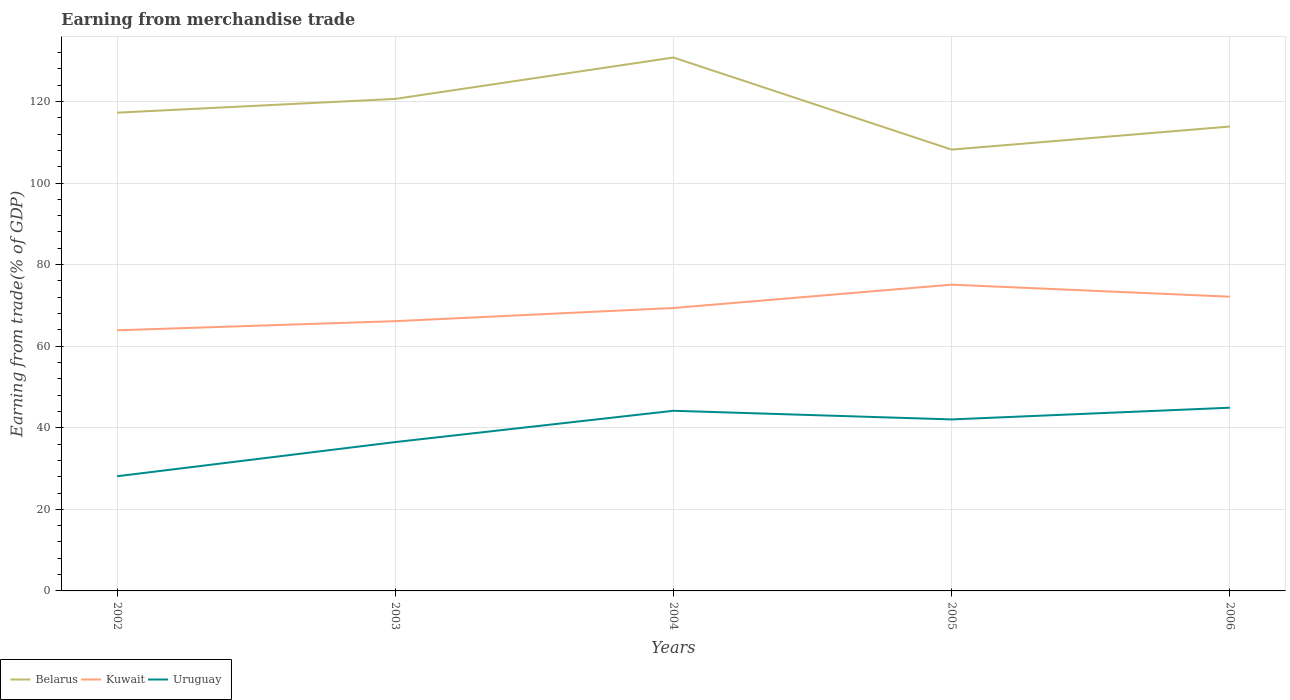Across all years, what is the maximum earnings from trade in Belarus?
Make the answer very short. 108.2. What is the total earnings from trade in Belarus in the graph?
Ensure brevity in your answer.  12.44. What is the difference between the highest and the second highest earnings from trade in Kuwait?
Your response must be concise. 11.19. What is the difference between the highest and the lowest earnings from trade in Kuwait?
Offer a very short reply. 3. How many lines are there?
Offer a very short reply. 3. What is the difference between two consecutive major ticks on the Y-axis?
Offer a terse response. 20. Does the graph contain any zero values?
Make the answer very short. No. Does the graph contain grids?
Offer a terse response. Yes. What is the title of the graph?
Give a very brief answer. Earning from merchandise trade. What is the label or title of the Y-axis?
Offer a very short reply. Earning from trade(% of GDP). What is the Earning from trade(% of GDP) of Belarus in 2002?
Give a very brief answer. 117.25. What is the Earning from trade(% of GDP) in Kuwait in 2002?
Offer a terse response. 63.9. What is the Earning from trade(% of GDP) in Uruguay in 2002?
Provide a short and direct response. 28.11. What is the Earning from trade(% of GDP) in Belarus in 2003?
Offer a terse response. 120.63. What is the Earning from trade(% of GDP) of Kuwait in 2003?
Offer a terse response. 66.14. What is the Earning from trade(% of GDP) of Uruguay in 2003?
Your response must be concise. 36.49. What is the Earning from trade(% of GDP) in Belarus in 2004?
Keep it short and to the point. 130.78. What is the Earning from trade(% of GDP) in Kuwait in 2004?
Offer a terse response. 69.36. What is the Earning from trade(% of GDP) of Uruguay in 2004?
Your answer should be compact. 44.17. What is the Earning from trade(% of GDP) of Belarus in 2005?
Your answer should be very brief. 108.2. What is the Earning from trade(% of GDP) in Kuwait in 2005?
Give a very brief answer. 75.09. What is the Earning from trade(% of GDP) in Uruguay in 2005?
Your answer should be compact. 42.05. What is the Earning from trade(% of GDP) in Belarus in 2006?
Provide a succinct answer. 113.86. What is the Earning from trade(% of GDP) in Kuwait in 2006?
Provide a succinct answer. 72.14. What is the Earning from trade(% of GDP) in Uruguay in 2006?
Offer a very short reply. 44.92. Across all years, what is the maximum Earning from trade(% of GDP) in Belarus?
Your answer should be compact. 130.78. Across all years, what is the maximum Earning from trade(% of GDP) of Kuwait?
Your answer should be very brief. 75.09. Across all years, what is the maximum Earning from trade(% of GDP) of Uruguay?
Offer a terse response. 44.92. Across all years, what is the minimum Earning from trade(% of GDP) of Belarus?
Provide a succinct answer. 108.2. Across all years, what is the minimum Earning from trade(% of GDP) of Kuwait?
Provide a succinct answer. 63.9. Across all years, what is the minimum Earning from trade(% of GDP) of Uruguay?
Your response must be concise. 28.11. What is the total Earning from trade(% of GDP) in Belarus in the graph?
Give a very brief answer. 590.73. What is the total Earning from trade(% of GDP) in Kuwait in the graph?
Make the answer very short. 346.63. What is the total Earning from trade(% of GDP) of Uruguay in the graph?
Offer a terse response. 195.74. What is the difference between the Earning from trade(% of GDP) of Belarus in 2002 and that in 2003?
Provide a short and direct response. -3.38. What is the difference between the Earning from trade(% of GDP) in Kuwait in 2002 and that in 2003?
Give a very brief answer. -2.24. What is the difference between the Earning from trade(% of GDP) of Uruguay in 2002 and that in 2003?
Offer a terse response. -8.38. What is the difference between the Earning from trade(% of GDP) of Belarus in 2002 and that in 2004?
Offer a terse response. -13.53. What is the difference between the Earning from trade(% of GDP) of Kuwait in 2002 and that in 2004?
Offer a very short reply. -5.46. What is the difference between the Earning from trade(% of GDP) in Uruguay in 2002 and that in 2004?
Give a very brief answer. -16.06. What is the difference between the Earning from trade(% of GDP) in Belarus in 2002 and that in 2005?
Your answer should be compact. 9.06. What is the difference between the Earning from trade(% of GDP) in Kuwait in 2002 and that in 2005?
Give a very brief answer. -11.19. What is the difference between the Earning from trade(% of GDP) of Uruguay in 2002 and that in 2005?
Your answer should be compact. -13.94. What is the difference between the Earning from trade(% of GDP) in Belarus in 2002 and that in 2006?
Your answer should be very brief. 3.39. What is the difference between the Earning from trade(% of GDP) in Kuwait in 2002 and that in 2006?
Your response must be concise. -8.24. What is the difference between the Earning from trade(% of GDP) of Uruguay in 2002 and that in 2006?
Offer a terse response. -16.81. What is the difference between the Earning from trade(% of GDP) in Belarus in 2003 and that in 2004?
Offer a very short reply. -10.15. What is the difference between the Earning from trade(% of GDP) in Kuwait in 2003 and that in 2004?
Keep it short and to the point. -3.22. What is the difference between the Earning from trade(% of GDP) of Uruguay in 2003 and that in 2004?
Make the answer very short. -7.67. What is the difference between the Earning from trade(% of GDP) of Belarus in 2003 and that in 2005?
Your response must be concise. 12.44. What is the difference between the Earning from trade(% of GDP) in Kuwait in 2003 and that in 2005?
Make the answer very short. -8.95. What is the difference between the Earning from trade(% of GDP) in Uruguay in 2003 and that in 2005?
Ensure brevity in your answer.  -5.55. What is the difference between the Earning from trade(% of GDP) in Belarus in 2003 and that in 2006?
Provide a succinct answer. 6.77. What is the difference between the Earning from trade(% of GDP) in Kuwait in 2003 and that in 2006?
Your response must be concise. -6. What is the difference between the Earning from trade(% of GDP) in Uruguay in 2003 and that in 2006?
Provide a succinct answer. -8.43. What is the difference between the Earning from trade(% of GDP) of Belarus in 2004 and that in 2005?
Provide a short and direct response. 22.58. What is the difference between the Earning from trade(% of GDP) of Kuwait in 2004 and that in 2005?
Make the answer very short. -5.72. What is the difference between the Earning from trade(% of GDP) of Uruguay in 2004 and that in 2005?
Your answer should be very brief. 2.12. What is the difference between the Earning from trade(% of GDP) of Belarus in 2004 and that in 2006?
Offer a very short reply. 16.92. What is the difference between the Earning from trade(% of GDP) of Kuwait in 2004 and that in 2006?
Ensure brevity in your answer.  -2.78. What is the difference between the Earning from trade(% of GDP) in Uruguay in 2004 and that in 2006?
Your response must be concise. -0.75. What is the difference between the Earning from trade(% of GDP) of Belarus in 2005 and that in 2006?
Your answer should be very brief. -5.66. What is the difference between the Earning from trade(% of GDP) in Kuwait in 2005 and that in 2006?
Keep it short and to the point. 2.95. What is the difference between the Earning from trade(% of GDP) of Uruguay in 2005 and that in 2006?
Your response must be concise. -2.87. What is the difference between the Earning from trade(% of GDP) of Belarus in 2002 and the Earning from trade(% of GDP) of Kuwait in 2003?
Provide a succinct answer. 51.11. What is the difference between the Earning from trade(% of GDP) in Belarus in 2002 and the Earning from trade(% of GDP) in Uruguay in 2003?
Provide a succinct answer. 80.76. What is the difference between the Earning from trade(% of GDP) in Kuwait in 2002 and the Earning from trade(% of GDP) in Uruguay in 2003?
Make the answer very short. 27.41. What is the difference between the Earning from trade(% of GDP) in Belarus in 2002 and the Earning from trade(% of GDP) in Kuwait in 2004?
Your answer should be compact. 47.89. What is the difference between the Earning from trade(% of GDP) in Belarus in 2002 and the Earning from trade(% of GDP) in Uruguay in 2004?
Provide a short and direct response. 73.09. What is the difference between the Earning from trade(% of GDP) of Kuwait in 2002 and the Earning from trade(% of GDP) of Uruguay in 2004?
Provide a succinct answer. 19.73. What is the difference between the Earning from trade(% of GDP) in Belarus in 2002 and the Earning from trade(% of GDP) in Kuwait in 2005?
Provide a short and direct response. 42.17. What is the difference between the Earning from trade(% of GDP) of Belarus in 2002 and the Earning from trade(% of GDP) of Uruguay in 2005?
Your response must be concise. 75.21. What is the difference between the Earning from trade(% of GDP) in Kuwait in 2002 and the Earning from trade(% of GDP) in Uruguay in 2005?
Offer a terse response. 21.85. What is the difference between the Earning from trade(% of GDP) of Belarus in 2002 and the Earning from trade(% of GDP) of Kuwait in 2006?
Make the answer very short. 45.11. What is the difference between the Earning from trade(% of GDP) in Belarus in 2002 and the Earning from trade(% of GDP) in Uruguay in 2006?
Your answer should be compact. 72.33. What is the difference between the Earning from trade(% of GDP) in Kuwait in 2002 and the Earning from trade(% of GDP) in Uruguay in 2006?
Your answer should be compact. 18.98. What is the difference between the Earning from trade(% of GDP) in Belarus in 2003 and the Earning from trade(% of GDP) in Kuwait in 2004?
Provide a succinct answer. 51.27. What is the difference between the Earning from trade(% of GDP) in Belarus in 2003 and the Earning from trade(% of GDP) in Uruguay in 2004?
Ensure brevity in your answer.  76.47. What is the difference between the Earning from trade(% of GDP) in Kuwait in 2003 and the Earning from trade(% of GDP) in Uruguay in 2004?
Ensure brevity in your answer.  21.97. What is the difference between the Earning from trade(% of GDP) in Belarus in 2003 and the Earning from trade(% of GDP) in Kuwait in 2005?
Give a very brief answer. 45.55. What is the difference between the Earning from trade(% of GDP) of Belarus in 2003 and the Earning from trade(% of GDP) of Uruguay in 2005?
Keep it short and to the point. 78.59. What is the difference between the Earning from trade(% of GDP) of Kuwait in 2003 and the Earning from trade(% of GDP) of Uruguay in 2005?
Your response must be concise. 24.09. What is the difference between the Earning from trade(% of GDP) in Belarus in 2003 and the Earning from trade(% of GDP) in Kuwait in 2006?
Give a very brief answer. 48.49. What is the difference between the Earning from trade(% of GDP) of Belarus in 2003 and the Earning from trade(% of GDP) of Uruguay in 2006?
Offer a very short reply. 75.71. What is the difference between the Earning from trade(% of GDP) in Kuwait in 2003 and the Earning from trade(% of GDP) in Uruguay in 2006?
Keep it short and to the point. 21.22. What is the difference between the Earning from trade(% of GDP) in Belarus in 2004 and the Earning from trade(% of GDP) in Kuwait in 2005?
Keep it short and to the point. 55.69. What is the difference between the Earning from trade(% of GDP) in Belarus in 2004 and the Earning from trade(% of GDP) in Uruguay in 2005?
Your answer should be very brief. 88.73. What is the difference between the Earning from trade(% of GDP) in Kuwait in 2004 and the Earning from trade(% of GDP) in Uruguay in 2005?
Provide a succinct answer. 27.31. What is the difference between the Earning from trade(% of GDP) of Belarus in 2004 and the Earning from trade(% of GDP) of Kuwait in 2006?
Make the answer very short. 58.64. What is the difference between the Earning from trade(% of GDP) in Belarus in 2004 and the Earning from trade(% of GDP) in Uruguay in 2006?
Offer a very short reply. 85.86. What is the difference between the Earning from trade(% of GDP) of Kuwait in 2004 and the Earning from trade(% of GDP) of Uruguay in 2006?
Provide a short and direct response. 24.44. What is the difference between the Earning from trade(% of GDP) of Belarus in 2005 and the Earning from trade(% of GDP) of Kuwait in 2006?
Your response must be concise. 36.06. What is the difference between the Earning from trade(% of GDP) of Belarus in 2005 and the Earning from trade(% of GDP) of Uruguay in 2006?
Provide a succinct answer. 63.28. What is the difference between the Earning from trade(% of GDP) in Kuwait in 2005 and the Earning from trade(% of GDP) in Uruguay in 2006?
Ensure brevity in your answer.  30.17. What is the average Earning from trade(% of GDP) in Belarus per year?
Provide a succinct answer. 118.15. What is the average Earning from trade(% of GDP) of Kuwait per year?
Keep it short and to the point. 69.33. What is the average Earning from trade(% of GDP) of Uruguay per year?
Provide a succinct answer. 39.15. In the year 2002, what is the difference between the Earning from trade(% of GDP) in Belarus and Earning from trade(% of GDP) in Kuwait?
Your answer should be compact. 53.35. In the year 2002, what is the difference between the Earning from trade(% of GDP) in Belarus and Earning from trade(% of GDP) in Uruguay?
Ensure brevity in your answer.  89.14. In the year 2002, what is the difference between the Earning from trade(% of GDP) of Kuwait and Earning from trade(% of GDP) of Uruguay?
Your response must be concise. 35.79. In the year 2003, what is the difference between the Earning from trade(% of GDP) of Belarus and Earning from trade(% of GDP) of Kuwait?
Provide a short and direct response. 54.49. In the year 2003, what is the difference between the Earning from trade(% of GDP) in Belarus and Earning from trade(% of GDP) in Uruguay?
Ensure brevity in your answer.  84.14. In the year 2003, what is the difference between the Earning from trade(% of GDP) in Kuwait and Earning from trade(% of GDP) in Uruguay?
Make the answer very short. 29.65. In the year 2004, what is the difference between the Earning from trade(% of GDP) of Belarus and Earning from trade(% of GDP) of Kuwait?
Your response must be concise. 61.42. In the year 2004, what is the difference between the Earning from trade(% of GDP) in Belarus and Earning from trade(% of GDP) in Uruguay?
Your response must be concise. 86.61. In the year 2004, what is the difference between the Earning from trade(% of GDP) in Kuwait and Earning from trade(% of GDP) in Uruguay?
Make the answer very short. 25.19. In the year 2005, what is the difference between the Earning from trade(% of GDP) in Belarus and Earning from trade(% of GDP) in Kuwait?
Offer a very short reply. 33.11. In the year 2005, what is the difference between the Earning from trade(% of GDP) in Belarus and Earning from trade(% of GDP) in Uruguay?
Give a very brief answer. 66.15. In the year 2005, what is the difference between the Earning from trade(% of GDP) in Kuwait and Earning from trade(% of GDP) in Uruguay?
Your answer should be very brief. 33.04. In the year 2006, what is the difference between the Earning from trade(% of GDP) of Belarus and Earning from trade(% of GDP) of Kuwait?
Your answer should be very brief. 41.72. In the year 2006, what is the difference between the Earning from trade(% of GDP) of Belarus and Earning from trade(% of GDP) of Uruguay?
Offer a terse response. 68.94. In the year 2006, what is the difference between the Earning from trade(% of GDP) of Kuwait and Earning from trade(% of GDP) of Uruguay?
Provide a succinct answer. 27.22. What is the ratio of the Earning from trade(% of GDP) in Kuwait in 2002 to that in 2003?
Make the answer very short. 0.97. What is the ratio of the Earning from trade(% of GDP) of Uruguay in 2002 to that in 2003?
Your response must be concise. 0.77. What is the ratio of the Earning from trade(% of GDP) of Belarus in 2002 to that in 2004?
Give a very brief answer. 0.9. What is the ratio of the Earning from trade(% of GDP) of Kuwait in 2002 to that in 2004?
Make the answer very short. 0.92. What is the ratio of the Earning from trade(% of GDP) of Uruguay in 2002 to that in 2004?
Provide a short and direct response. 0.64. What is the ratio of the Earning from trade(% of GDP) of Belarus in 2002 to that in 2005?
Provide a succinct answer. 1.08. What is the ratio of the Earning from trade(% of GDP) in Kuwait in 2002 to that in 2005?
Keep it short and to the point. 0.85. What is the ratio of the Earning from trade(% of GDP) in Uruguay in 2002 to that in 2005?
Your answer should be very brief. 0.67. What is the ratio of the Earning from trade(% of GDP) in Belarus in 2002 to that in 2006?
Offer a very short reply. 1.03. What is the ratio of the Earning from trade(% of GDP) of Kuwait in 2002 to that in 2006?
Offer a terse response. 0.89. What is the ratio of the Earning from trade(% of GDP) of Uruguay in 2002 to that in 2006?
Keep it short and to the point. 0.63. What is the ratio of the Earning from trade(% of GDP) of Belarus in 2003 to that in 2004?
Your response must be concise. 0.92. What is the ratio of the Earning from trade(% of GDP) of Kuwait in 2003 to that in 2004?
Offer a terse response. 0.95. What is the ratio of the Earning from trade(% of GDP) of Uruguay in 2003 to that in 2004?
Give a very brief answer. 0.83. What is the ratio of the Earning from trade(% of GDP) in Belarus in 2003 to that in 2005?
Give a very brief answer. 1.11. What is the ratio of the Earning from trade(% of GDP) of Kuwait in 2003 to that in 2005?
Ensure brevity in your answer.  0.88. What is the ratio of the Earning from trade(% of GDP) of Uruguay in 2003 to that in 2005?
Your answer should be compact. 0.87. What is the ratio of the Earning from trade(% of GDP) of Belarus in 2003 to that in 2006?
Your answer should be very brief. 1.06. What is the ratio of the Earning from trade(% of GDP) in Kuwait in 2003 to that in 2006?
Your answer should be very brief. 0.92. What is the ratio of the Earning from trade(% of GDP) in Uruguay in 2003 to that in 2006?
Offer a very short reply. 0.81. What is the ratio of the Earning from trade(% of GDP) of Belarus in 2004 to that in 2005?
Offer a terse response. 1.21. What is the ratio of the Earning from trade(% of GDP) of Kuwait in 2004 to that in 2005?
Your answer should be compact. 0.92. What is the ratio of the Earning from trade(% of GDP) of Uruguay in 2004 to that in 2005?
Give a very brief answer. 1.05. What is the ratio of the Earning from trade(% of GDP) in Belarus in 2004 to that in 2006?
Make the answer very short. 1.15. What is the ratio of the Earning from trade(% of GDP) of Kuwait in 2004 to that in 2006?
Your answer should be compact. 0.96. What is the ratio of the Earning from trade(% of GDP) of Uruguay in 2004 to that in 2006?
Your answer should be very brief. 0.98. What is the ratio of the Earning from trade(% of GDP) in Belarus in 2005 to that in 2006?
Offer a very short reply. 0.95. What is the ratio of the Earning from trade(% of GDP) in Kuwait in 2005 to that in 2006?
Keep it short and to the point. 1.04. What is the ratio of the Earning from trade(% of GDP) of Uruguay in 2005 to that in 2006?
Your answer should be compact. 0.94. What is the difference between the highest and the second highest Earning from trade(% of GDP) in Belarus?
Provide a short and direct response. 10.15. What is the difference between the highest and the second highest Earning from trade(% of GDP) in Kuwait?
Provide a short and direct response. 2.95. What is the difference between the highest and the second highest Earning from trade(% of GDP) of Uruguay?
Your answer should be compact. 0.75. What is the difference between the highest and the lowest Earning from trade(% of GDP) in Belarus?
Keep it short and to the point. 22.58. What is the difference between the highest and the lowest Earning from trade(% of GDP) in Kuwait?
Your answer should be compact. 11.19. What is the difference between the highest and the lowest Earning from trade(% of GDP) of Uruguay?
Ensure brevity in your answer.  16.81. 